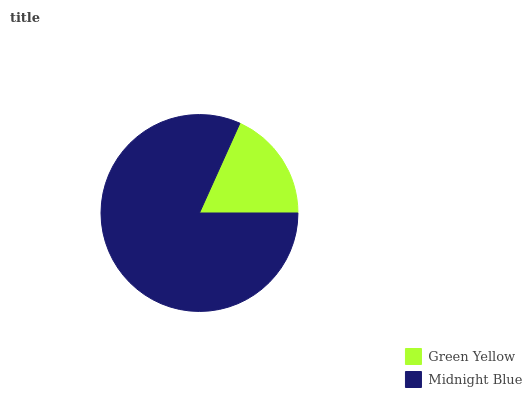Is Green Yellow the minimum?
Answer yes or no. Yes. Is Midnight Blue the maximum?
Answer yes or no. Yes. Is Midnight Blue the minimum?
Answer yes or no. No. Is Midnight Blue greater than Green Yellow?
Answer yes or no. Yes. Is Green Yellow less than Midnight Blue?
Answer yes or no. Yes. Is Green Yellow greater than Midnight Blue?
Answer yes or no. No. Is Midnight Blue less than Green Yellow?
Answer yes or no. No. Is Midnight Blue the high median?
Answer yes or no. Yes. Is Green Yellow the low median?
Answer yes or no. Yes. Is Green Yellow the high median?
Answer yes or no. No. Is Midnight Blue the low median?
Answer yes or no. No. 